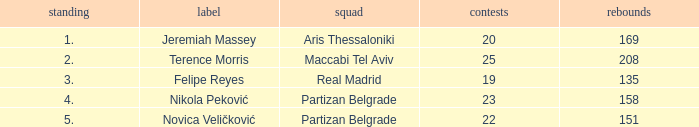What is the number of Games for the Maccabi Tel Aviv Team with less than 208 Rebounds? None. 